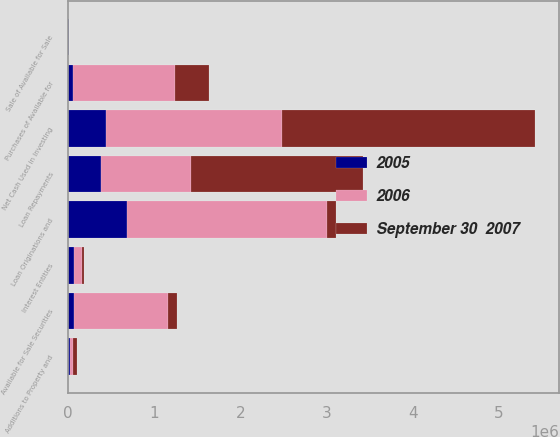<chart> <loc_0><loc_0><loc_500><loc_500><stacked_bar_chart><ecel><fcel>Additions to Property and<fcel>Loan Originations and<fcel>Loan Repayments<fcel>Interest Entities<fcel>Sale of Available for Sale<fcel>Purchases of Available for<fcel>Available for Sale Securities<fcel>Net Cash Used in Investing<nl><fcel>September 30  2007<fcel>46081<fcel>102700<fcel>1.99782e+06<fcel>18078<fcel>81<fcel>396450<fcel>102700<fcel>2.93386e+06<nl><fcel>2006<fcel>27280<fcel>2.31883e+06<fcel>1.04402e+06<fcel>89735<fcel>252<fcel>1.18041e+06<fcel>1.08762e+06<fcel>2.04291e+06<nl><fcel>2005<fcel>30154<fcel>691302<fcel>379298<fcel>75967<fcel>9250<fcel>60536<fcel>71671<fcel>444026<nl></chart> 